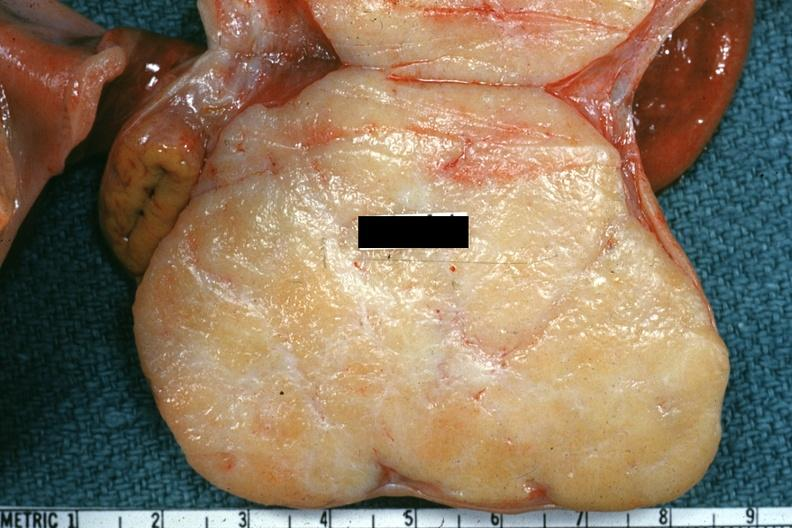s female reproductive present?
Answer the question using a single word or phrase. Yes 